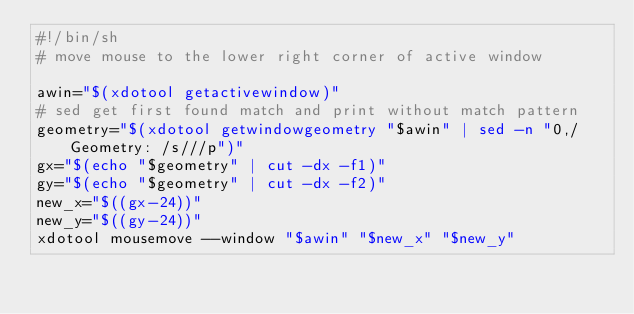Convert code to text. <code><loc_0><loc_0><loc_500><loc_500><_Bash_>#!/bin/sh
# move mouse to the lower right corner of active window

awin="$(xdotool getactivewindow)"
# sed get first found match and print without match pattern
geometry="$(xdotool getwindowgeometry "$awin" | sed -n "0,/  Geometry: /s///p")"
gx="$(echo "$geometry" | cut -dx -f1)"
gy="$(echo "$geometry" | cut -dx -f2)"
new_x="$((gx-24))"
new_y="$((gy-24))"
xdotool mousemove --window "$awin" "$new_x" "$new_y"
</code> 